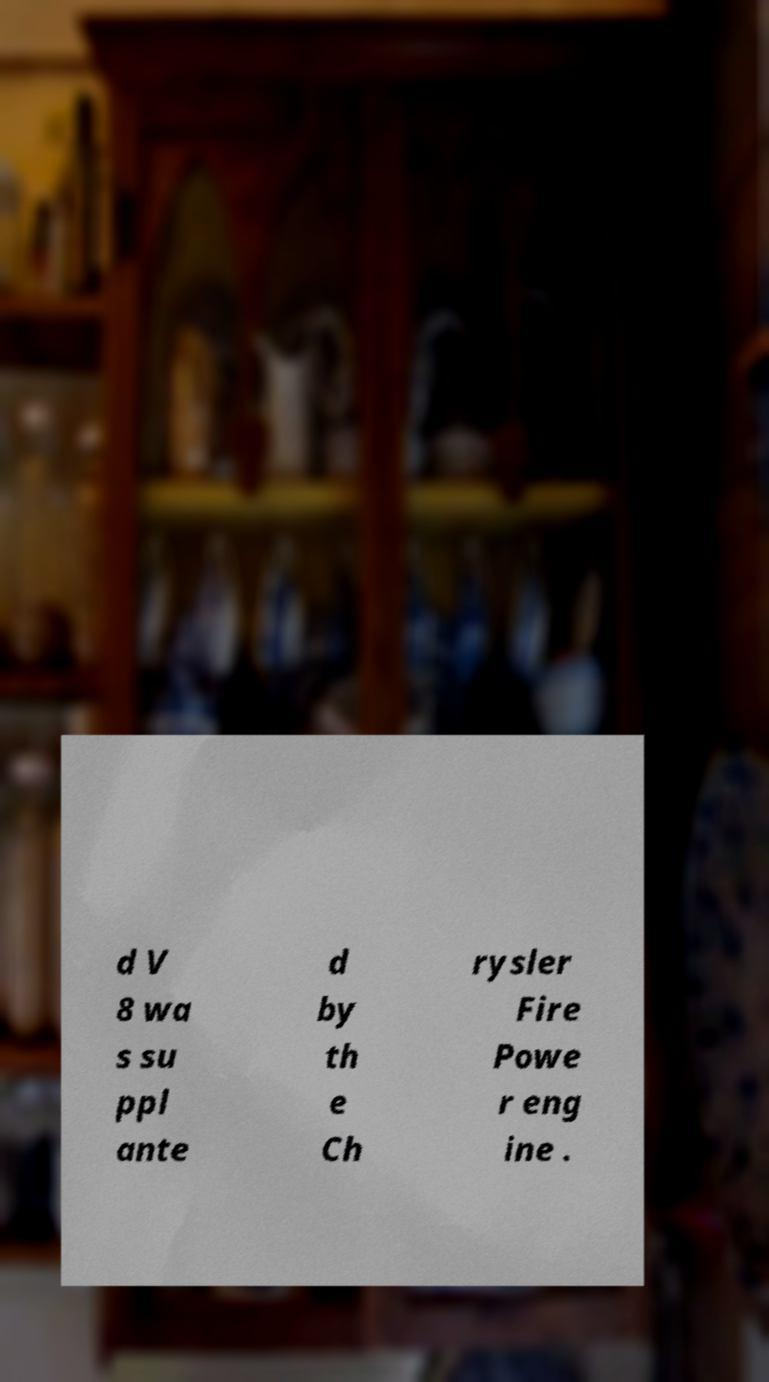For documentation purposes, I need the text within this image transcribed. Could you provide that? d V 8 wa s su ppl ante d by th e Ch rysler Fire Powe r eng ine . 